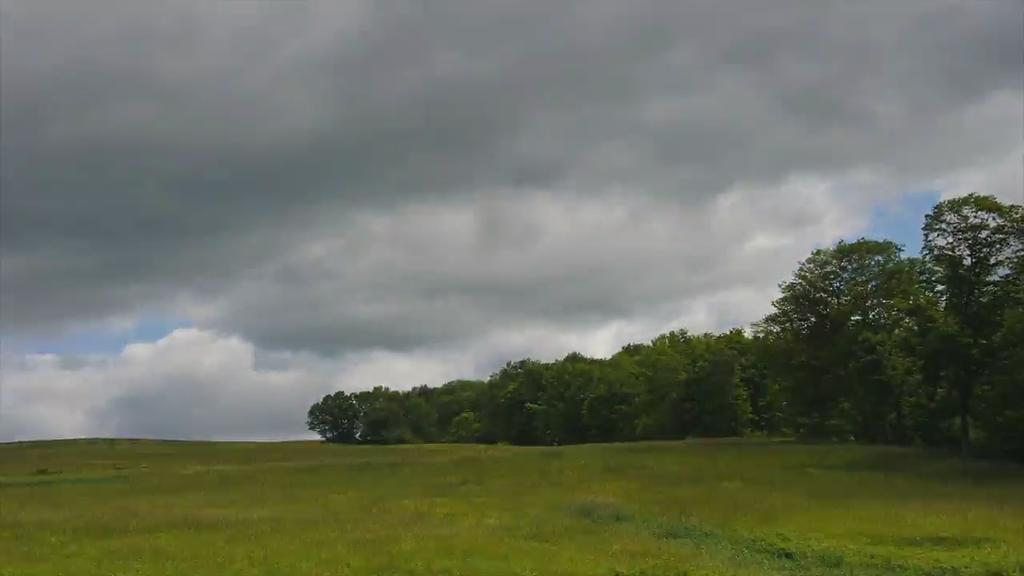What type of vegetation can be seen in the image? There is grass in the image. What other natural elements are present in the image? There are trees in the image. What can be seen in the background of the image? The sky is visible in the background of the image. What is the condition of the sky in the image? Clouds are present in the sky. What type of cap can be seen on the clock in the image? There is no cap or clock present in the image; it features grass, trees, and a sky with clouds. 